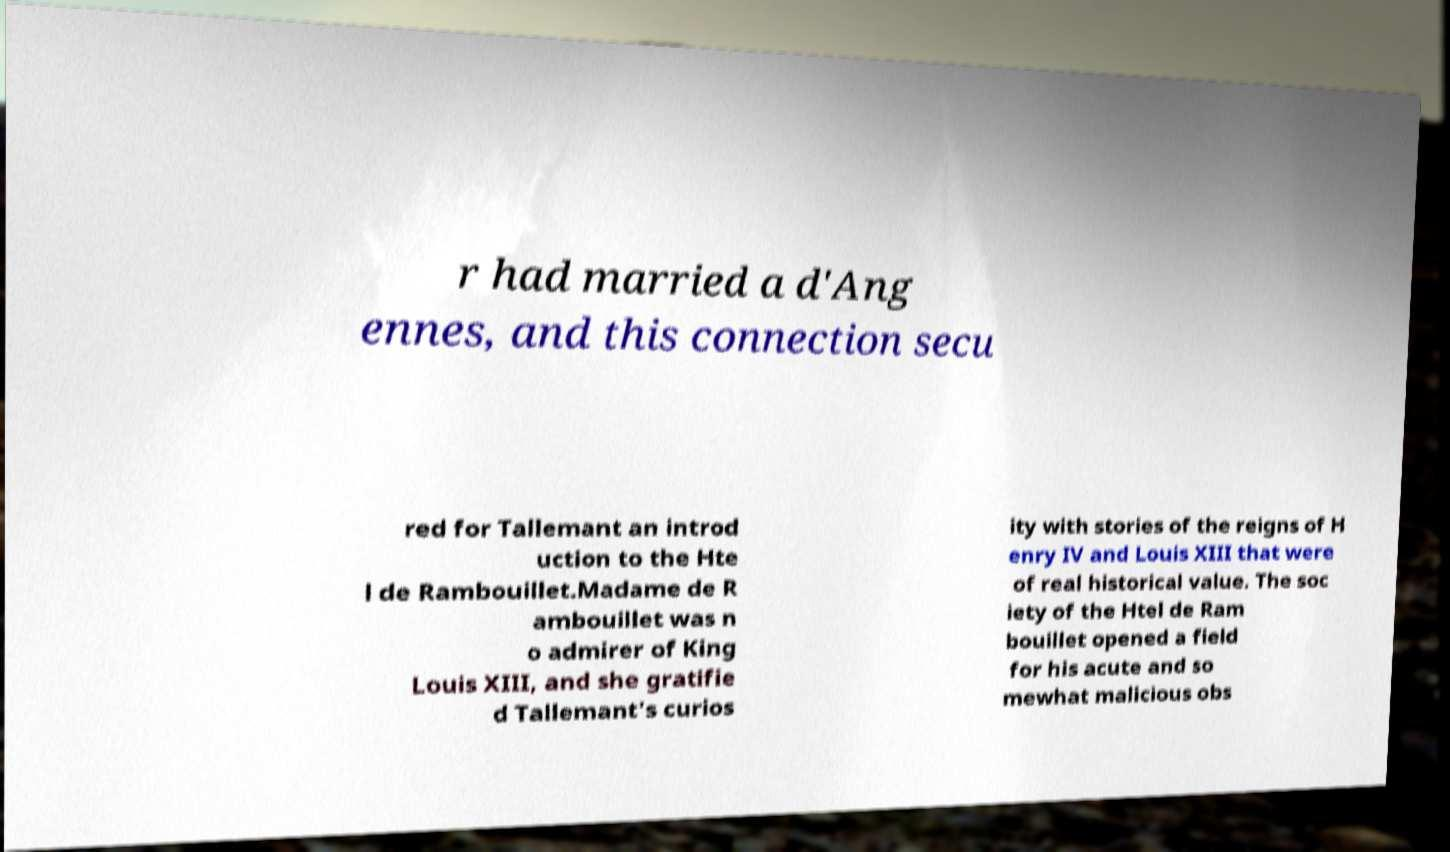What messages or text are displayed in this image? I need them in a readable, typed format. r had married a d'Ang ennes, and this connection secu red for Tallemant an introd uction to the Hte l de Rambouillet.Madame de R ambouillet was n o admirer of King Louis XIII, and she gratifie d Tallemant's curios ity with stories of the reigns of H enry IV and Louis XIII that were of real historical value. The soc iety of the Htel de Ram bouillet opened a field for his acute and so mewhat malicious obs 